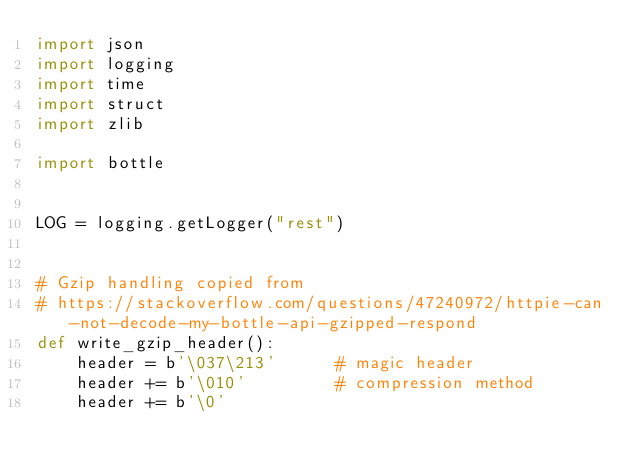Convert code to text. <code><loc_0><loc_0><loc_500><loc_500><_Python_>import json
import logging
import time
import struct
import zlib

import bottle


LOG = logging.getLogger("rest")


# Gzip handling copied from
# https://stackoverflow.com/questions/47240972/httpie-can-not-decode-my-bottle-api-gzipped-respond
def write_gzip_header():
    header = b'\037\213'      # magic header
    header += b'\010'         # compression method
    header += b'\0'</code> 